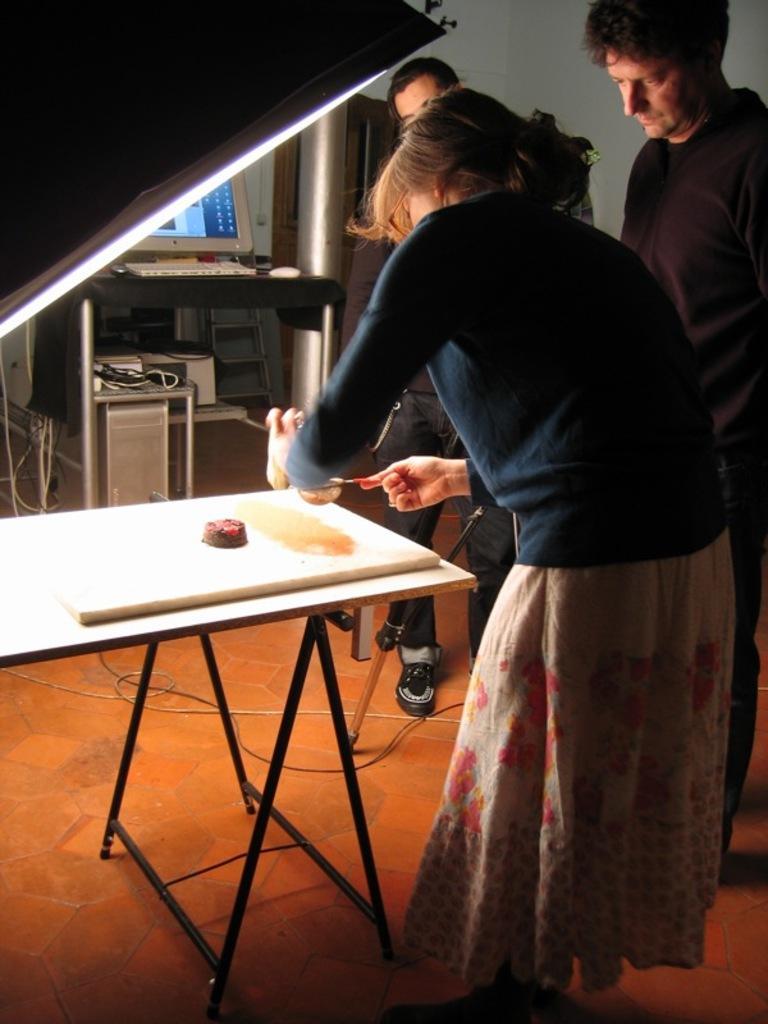Please provide a concise description of this image. In this picture we can see three people standing around the table and a lady among them is doing something on the table. 